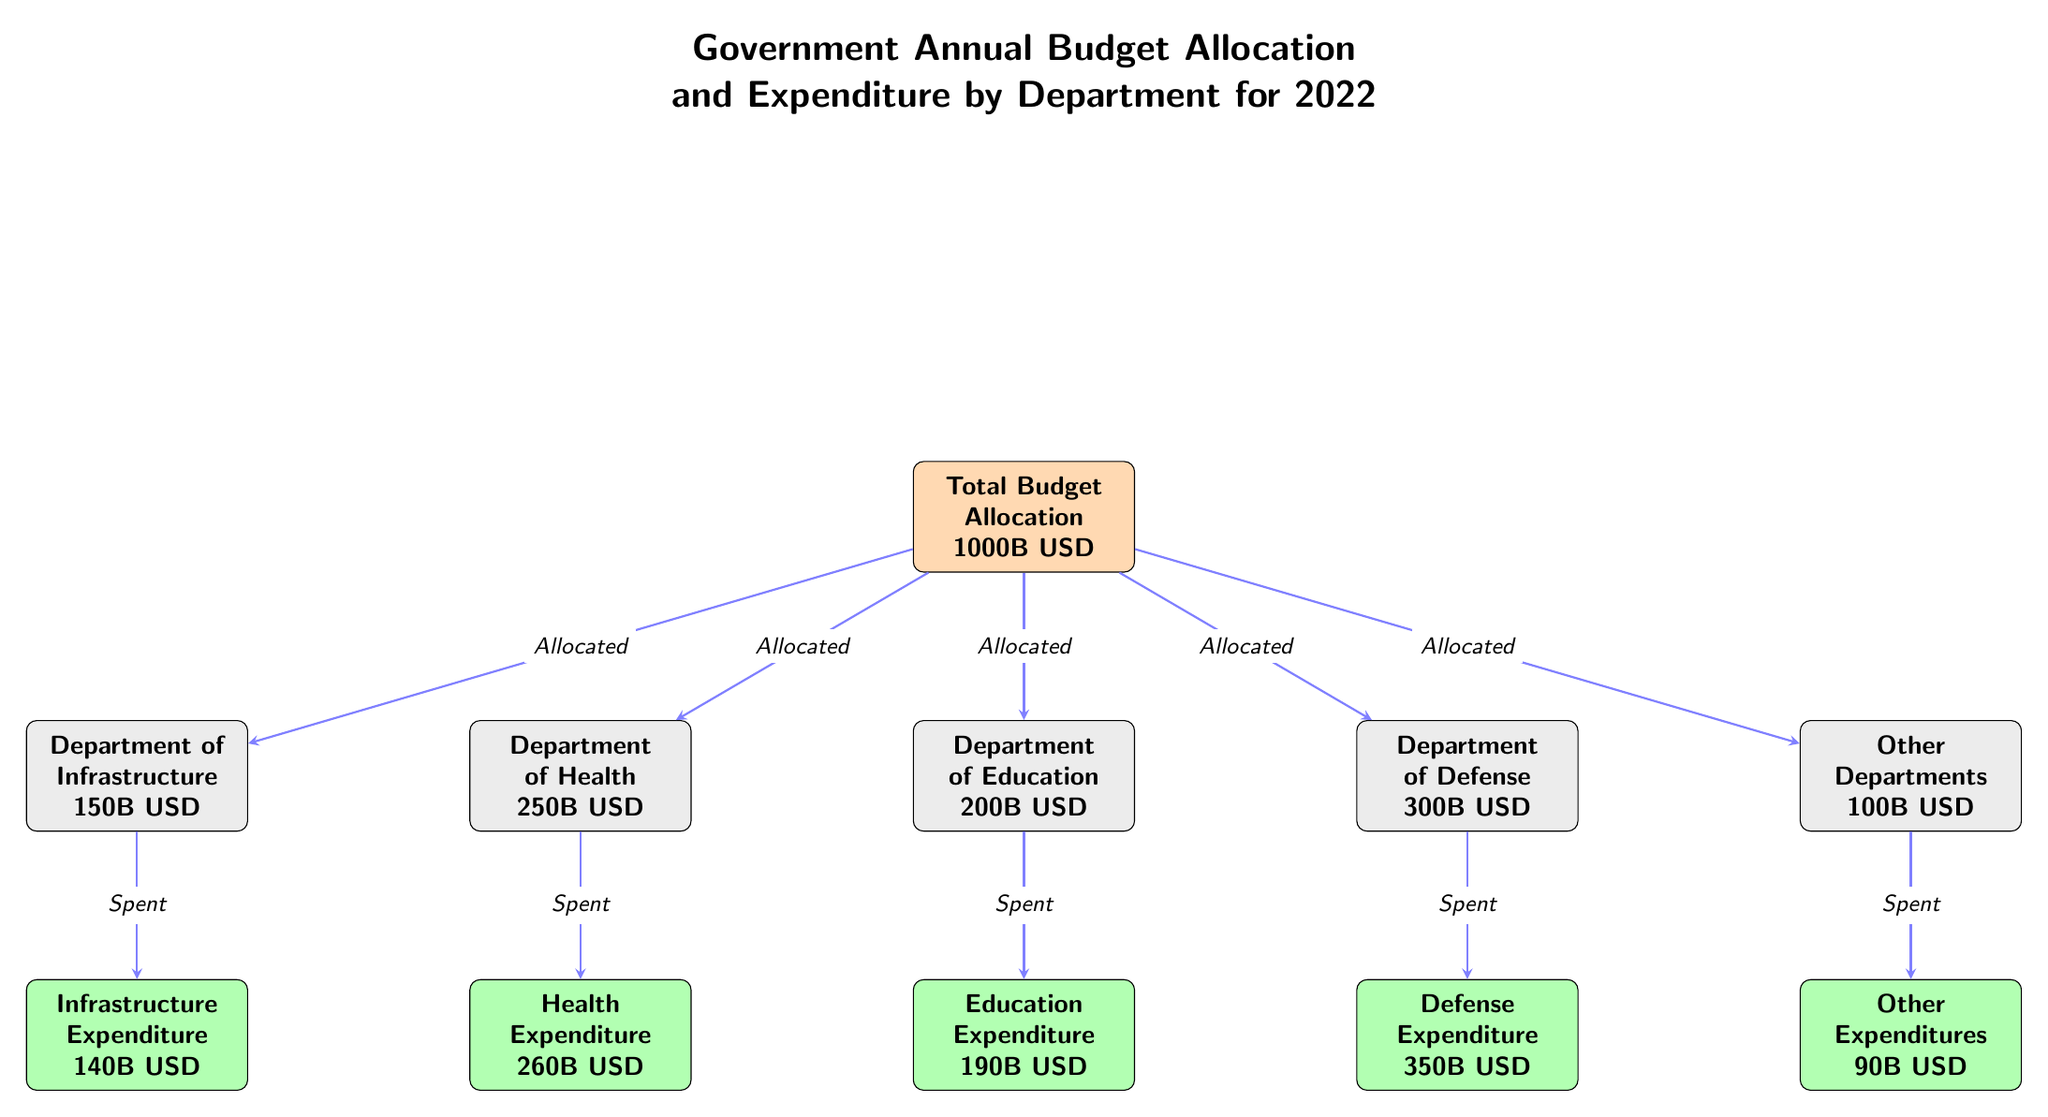What is the total budget allocation for 2022? The main node labeled "Total Budget Allocation" indicates 1000B USD.
Answer: 1000B USD How much is allocated to the Department of Defense? The node for the Department of Defense states "300B USD" for the allocated budget.
Answer: 300B USD What is the expenditure for the Department of Education? The node "Education Expenditure" shows the amount spent as "190B USD."
Answer: 190B USD How much was spent on Health? The "Health Expenditure" node displays the spending amount of "260B USD."
Answer: 260B USD Which department had the highest expenditure? By comparing the expenditure nodes, "Defense Expenditure" at 350B USD is the highest amount.
Answer: Defense What is the difference between the allocated budget for the Department of Health and its expenditure? The allocated budget for Health is 250B USD (allocated) and 260B USD (spent). The difference: 260 - 250 = 10B USD.
Answer: 10B USD How much total was spent on Other Expenditures? The node labeled "Other Expenditures" shows an amount of 90B USD spent.
Answer: 90B USD Which department has the lowest allocation? The Department of Infrastructure shows the lowest allocation with "150B USD."
Answer: Department of Infrastructure What percentage of the total budget was allocated to the Department of Education? The calculation is (200B USD / 1000B USD) * 100 = 20%.
Answer: 20% What is the total expenditure spent on all departments combined? Summing the expenditures: 260 + 190 + 350 + 140 + 90 = 1030B USD.
Answer: 1030B USD 